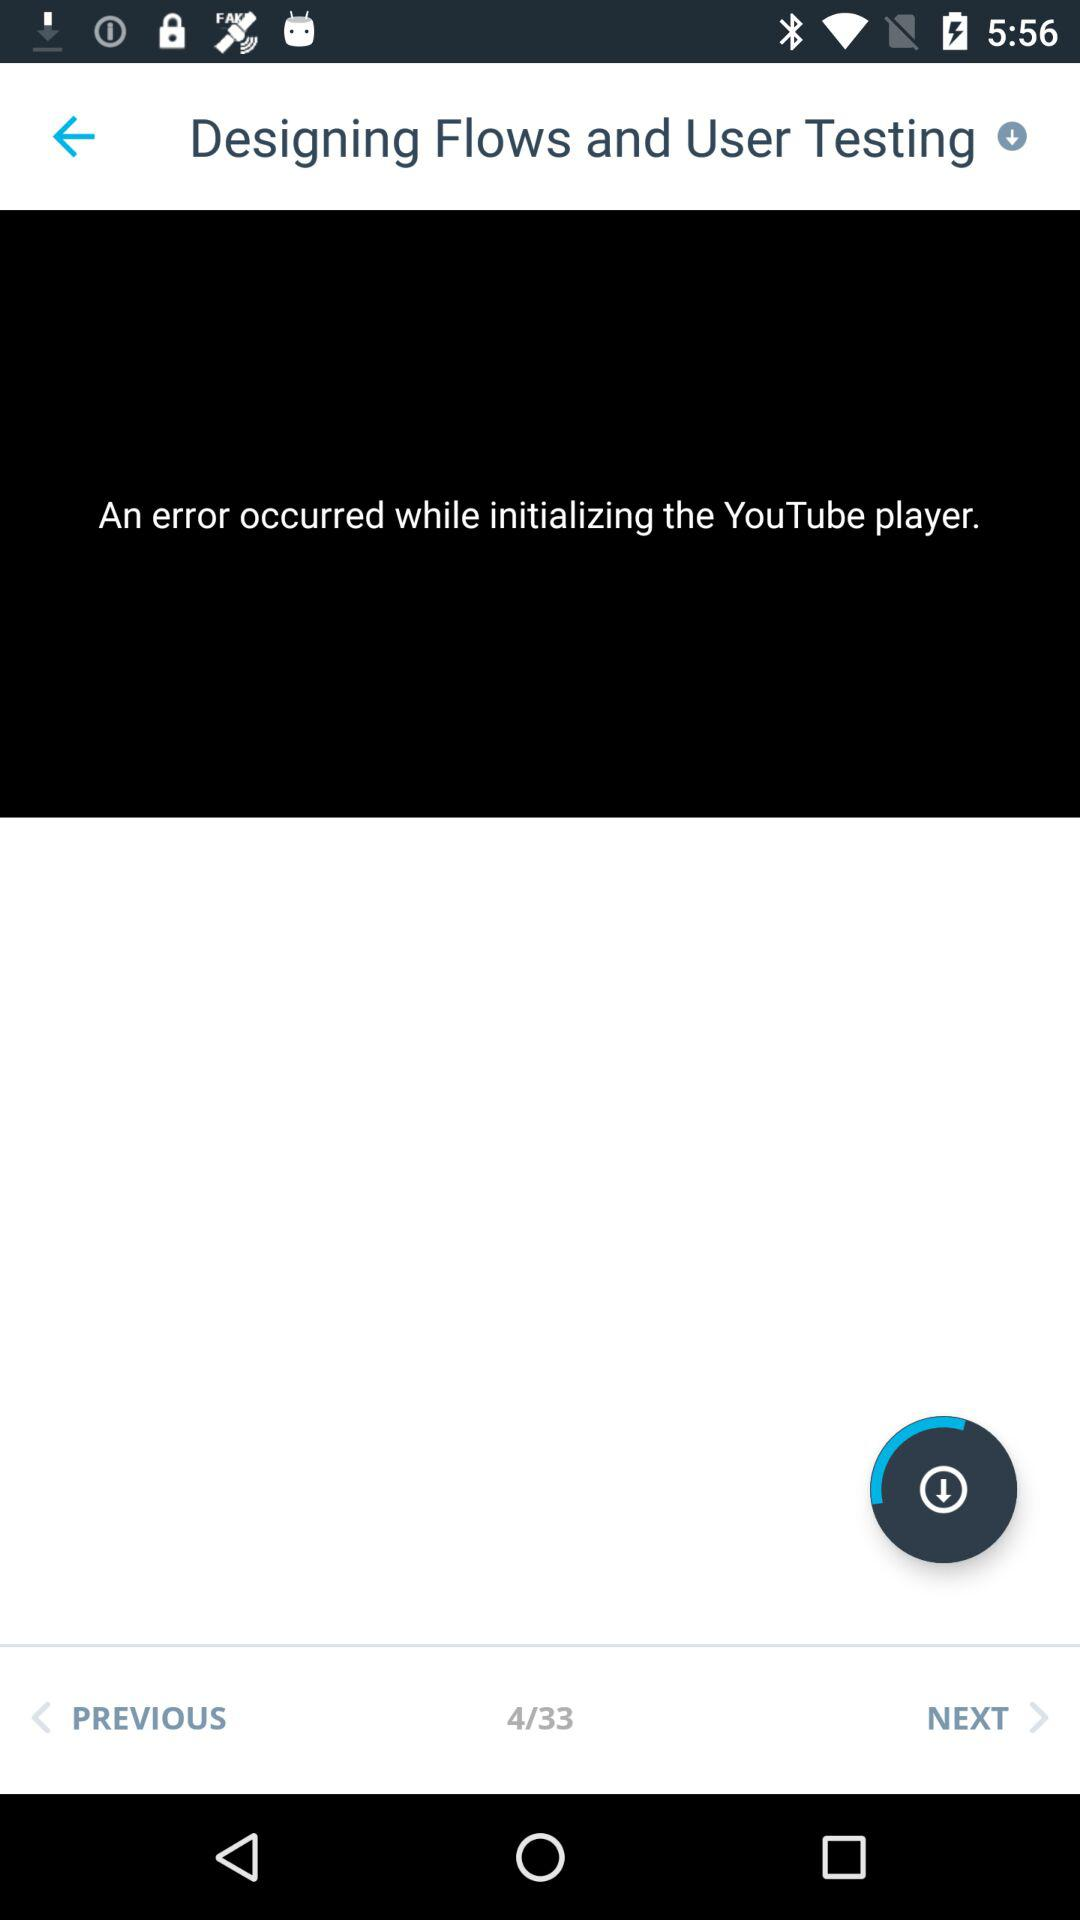What is the current page number displayed? The current page number is 4. 